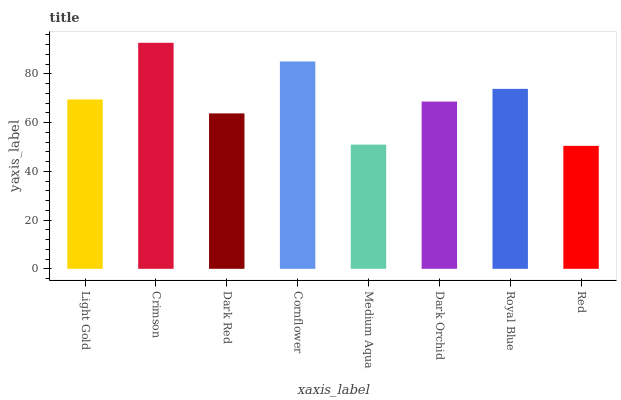Is Red the minimum?
Answer yes or no. Yes. Is Crimson the maximum?
Answer yes or no. Yes. Is Dark Red the minimum?
Answer yes or no. No. Is Dark Red the maximum?
Answer yes or no. No. Is Crimson greater than Dark Red?
Answer yes or no. Yes. Is Dark Red less than Crimson?
Answer yes or no. Yes. Is Dark Red greater than Crimson?
Answer yes or no. No. Is Crimson less than Dark Red?
Answer yes or no. No. Is Light Gold the high median?
Answer yes or no. Yes. Is Dark Orchid the low median?
Answer yes or no. Yes. Is Cornflower the high median?
Answer yes or no. No. Is Cornflower the low median?
Answer yes or no. No. 